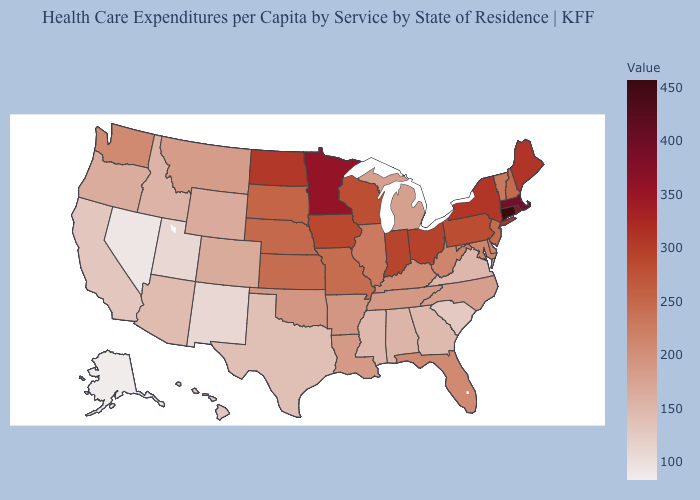Does Arkansas have a lower value than Connecticut?
Answer briefly. Yes. Which states have the highest value in the USA?
Keep it brief. Connecticut. Among the states that border North Carolina , which have the lowest value?
Concise answer only. South Carolina. Which states have the lowest value in the USA?
Quick response, please. Alaska. 